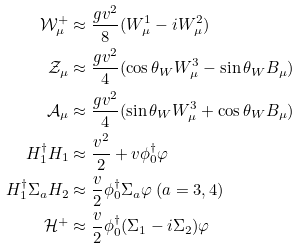Convert formula to latex. <formula><loc_0><loc_0><loc_500><loc_500>\mathcal { W } ^ { + } _ { \mu } & \approx \frac { g v ^ { 2 } } { 8 } ( W _ { \mu } ^ { 1 } - i W _ { \mu } ^ { 2 } ) \\ \mathcal { Z } _ { \mu } & \approx \frac { g v ^ { 2 } } { 4 } ( \cos \theta _ { W } W _ { \mu } ^ { 3 } - \sin \theta _ { W } B _ { \mu } ) \\ \mathcal { A } _ { \mu } & \approx \frac { g v ^ { 2 } } { 4 } ( \sin \theta _ { W } W _ { \mu } ^ { 3 } + \cos \theta _ { W } B _ { \mu } ) \\ H ^ { \dagger } _ { 1 } H _ { 1 } & \approx \frac { v ^ { 2 } } { 2 } + v \phi _ { 0 } ^ { \dagger } \varphi \\ H ^ { \dagger } _ { 1 } \Sigma _ { a } H _ { 2 } & \approx \frac { v } { 2 } \phi _ { 0 } ^ { \dagger } \Sigma _ { a } \varphi \ ( a = 3 , 4 ) \\ \mathcal { H } ^ { + } & \approx \frac { v } { 2 } \phi _ { 0 } ^ { \dagger } ( \Sigma _ { 1 } - i \Sigma _ { 2 } ) \varphi</formula> 